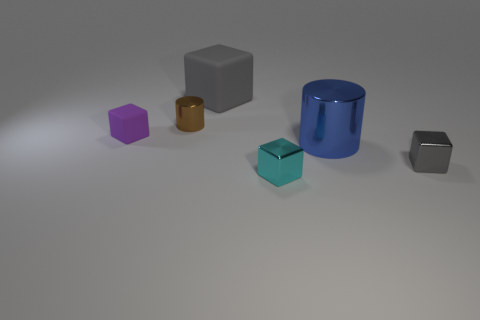Can you tell me what time of day it might be in this scene? The lighting in the image suggests it is an indoor scene with artificial lighting, since there are soft shadows indicating a light source like a lamp, therefore we cannot deduce the time of day from this image.  Are there any other objects that might provide context to the scene? The image mainly shows individual geometric shapes spread across a plain surface. There are no additional objects that give direct context or hints about the environment or the purpose of this arrangement. 